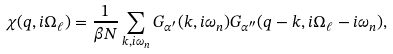Convert formula to latex. <formula><loc_0><loc_0><loc_500><loc_500>\chi ( { q } , i \Omega _ { \ell } ) = \frac { 1 } { \beta N } \sum _ { { k } , i \omega _ { n } } G _ { \alpha ^ { \prime } } ( { k } , i \omega _ { n } ) G _ { \alpha ^ { \prime \prime } } ( { q - k } , i \Omega _ { \ell } - i \omega _ { n } ) ,</formula> 